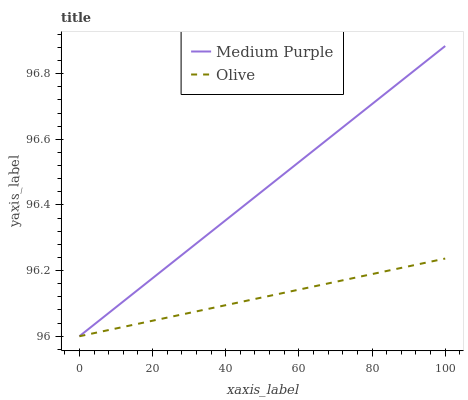Does Olive have the minimum area under the curve?
Answer yes or no. Yes. Does Medium Purple have the maximum area under the curve?
Answer yes or no. Yes. Does Olive have the maximum area under the curve?
Answer yes or no. No. Is Olive the smoothest?
Answer yes or no. Yes. Is Medium Purple the roughest?
Answer yes or no. Yes. Is Olive the roughest?
Answer yes or no. No. Does Medium Purple have the lowest value?
Answer yes or no. Yes. Does Medium Purple have the highest value?
Answer yes or no. Yes. Does Olive have the highest value?
Answer yes or no. No. Does Medium Purple intersect Olive?
Answer yes or no. Yes. Is Medium Purple less than Olive?
Answer yes or no. No. Is Medium Purple greater than Olive?
Answer yes or no. No. 